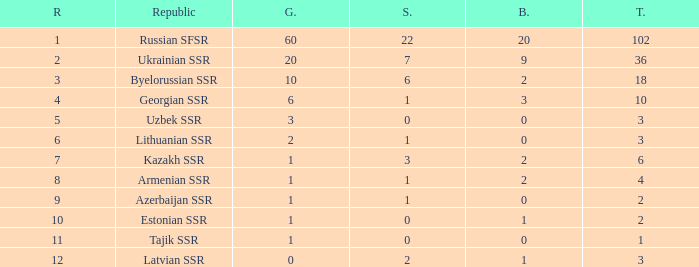What is the total number of bronzes associated with 1 silver, ranks under 6 and under 6 golds? None. 